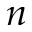Convert formula to latex. <formula><loc_0><loc_0><loc_500><loc_500>n</formula> 